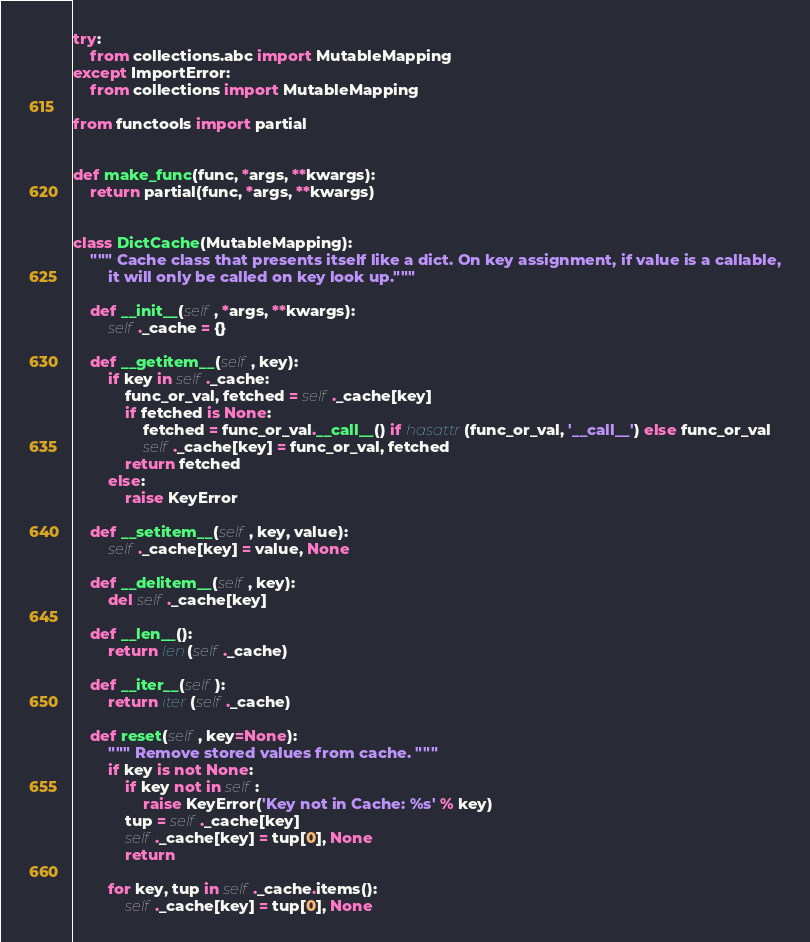<code> <loc_0><loc_0><loc_500><loc_500><_Python_>try:
    from collections.abc import MutableMapping
except ImportError:
    from collections import MutableMapping

from functools import partial


def make_func(func, *args, **kwargs):
    return partial(func, *args, **kwargs)


class DictCache(MutableMapping):
    """ Cache class that presents itself like a dict. On key assignment, if value is a callable,
        it will only be called on key look up."""
    
    def __init__(self, *args, **kwargs):
        self._cache = {}

    def __getitem__(self, key):
        if key in self._cache:
            func_or_val, fetched = self._cache[key]
            if fetched is None:
                fetched = func_or_val.__call__() if hasattr(func_or_val, '__call__') else func_or_val
                self._cache[key] = func_or_val, fetched
            return fetched
        else:
            raise KeyError

    def __setitem__(self, key, value):
        self._cache[key] = value, None

    def __delitem__(self, key):
        del self._cache[key]

    def __len__():
        return len(self._cache)

    def __iter__(self):
        return iter(self._cache)

    def reset(self, key=None):
        """ Remove stored values from cache. """
        if key is not None:
            if key not in self:
                raise KeyError('Key not in Cache: %s' % key)
            tup = self._cache[key]
            self._cache[key] = tup[0], None
            return
        
        for key, tup in self._cache.items():
            self._cache[key] = tup[0], None

</code> 